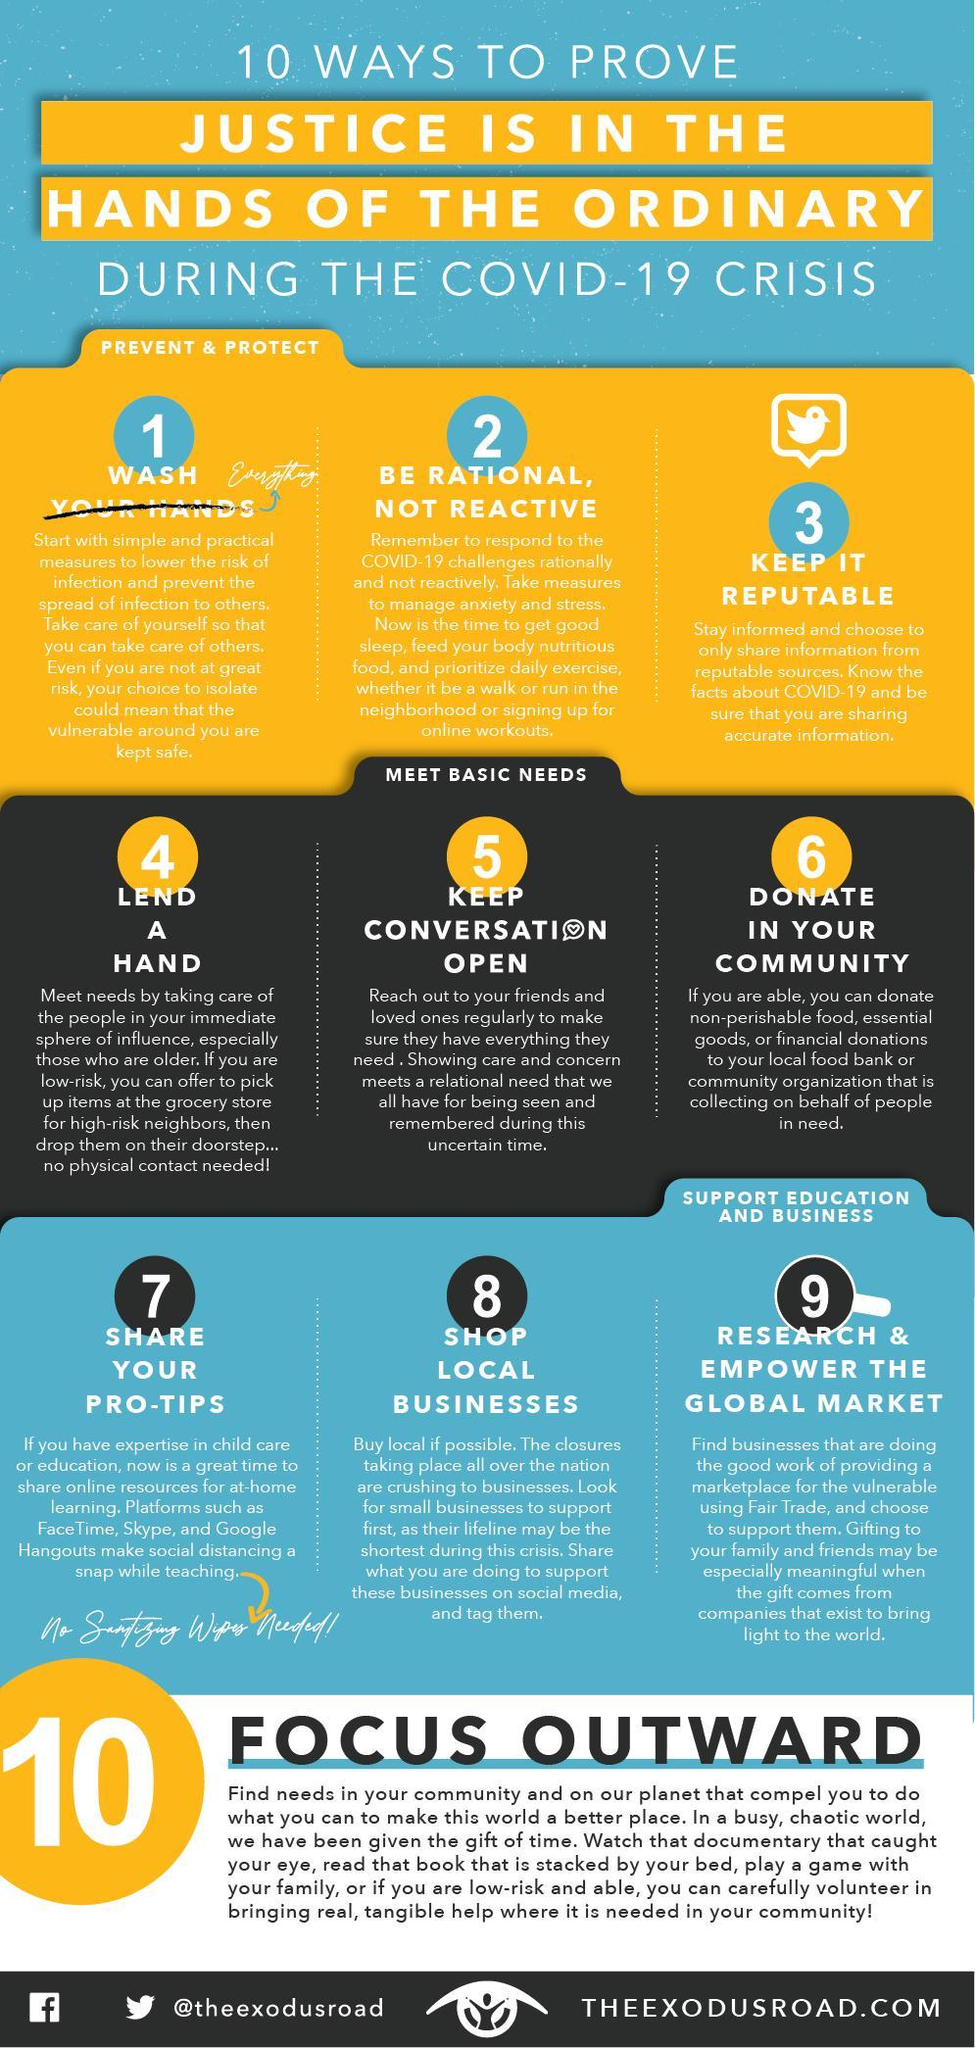Which all applications can help while teaching online?
Answer the question with a short phrase. FaceTime, Skype, and Google Hangouts How can someone help their elderly neighbors? pick up items at the grocery store Which type of businesses should we support in crisis times - corporates, local or international? local 